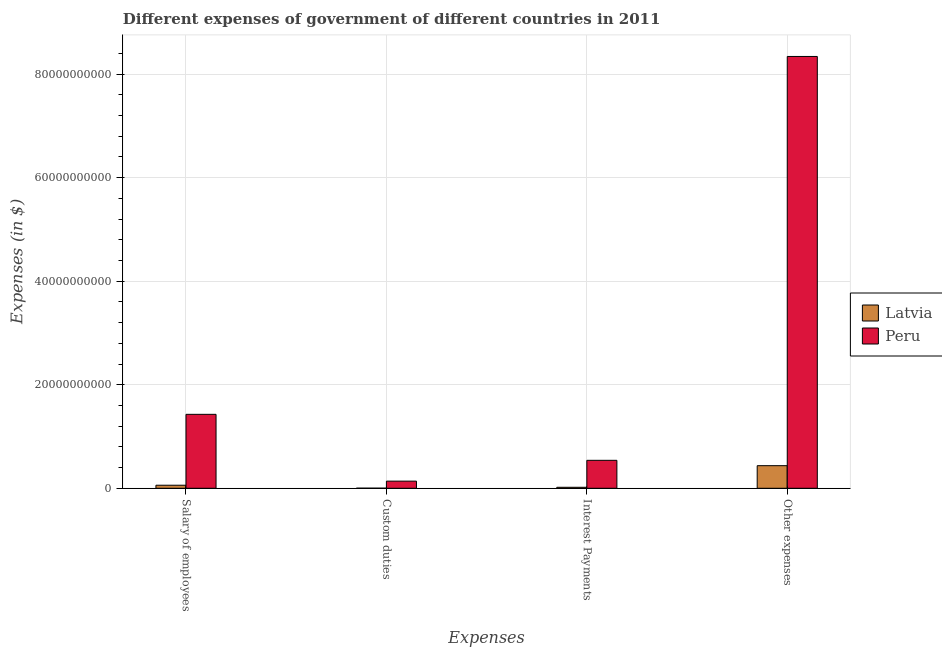How many different coloured bars are there?
Your answer should be compact. 2. How many bars are there on the 4th tick from the left?
Your answer should be very brief. 2. How many bars are there on the 4th tick from the right?
Keep it short and to the point. 2. What is the label of the 1st group of bars from the left?
Offer a terse response. Salary of employees. What is the amount spent on interest payments in Peru?
Offer a terse response. 5.40e+09. Across all countries, what is the maximum amount spent on interest payments?
Your response must be concise. 5.40e+09. Across all countries, what is the minimum amount spent on other expenses?
Your answer should be compact. 4.37e+09. In which country was the amount spent on custom duties minimum?
Keep it short and to the point. Latvia. What is the total amount spent on interest payments in the graph?
Your answer should be very brief. 5.59e+09. What is the difference between the amount spent on custom duties in Latvia and that in Peru?
Offer a very short reply. -1.36e+09. What is the difference between the amount spent on interest payments in Latvia and the amount spent on other expenses in Peru?
Provide a short and direct response. -8.32e+1. What is the average amount spent on custom duties per country?
Make the answer very short. 7.01e+08. What is the difference between the amount spent on interest payments and amount spent on other expenses in Peru?
Ensure brevity in your answer.  -7.80e+1. In how many countries, is the amount spent on custom duties greater than 68000000000 $?
Provide a succinct answer. 0. What is the ratio of the amount spent on custom duties in Peru to that in Latvia?
Your answer should be very brief. 66.15. Is the amount spent on custom duties in Latvia less than that in Peru?
Your response must be concise. Yes. Is the difference between the amount spent on custom duties in Peru and Latvia greater than the difference between the amount spent on salary of employees in Peru and Latvia?
Your response must be concise. No. What is the difference between the highest and the second highest amount spent on salary of employees?
Make the answer very short. 1.37e+1. What is the difference between the highest and the lowest amount spent on custom duties?
Your answer should be very brief. 1.36e+09. In how many countries, is the amount spent on other expenses greater than the average amount spent on other expenses taken over all countries?
Provide a succinct answer. 1. Is it the case that in every country, the sum of the amount spent on other expenses and amount spent on salary of employees is greater than the sum of amount spent on custom duties and amount spent on interest payments?
Your response must be concise. No. What does the 1st bar from the left in Interest Payments represents?
Your answer should be compact. Latvia. What does the 2nd bar from the right in Interest Payments represents?
Your response must be concise. Latvia. How many countries are there in the graph?
Keep it short and to the point. 2. Does the graph contain grids?
Your answer should be very brief. Yes. How many legend labels are there?
Give a very brief answer. 2. What is the title of the graph?
Give a very brief answer. Different expenses of government of different countries in 2011. Does "Sierra Leone" appear as one of the legend labels in the graph?
Your response must be concise. No. What is the label or title of the X-axis?
Offer a terse response. Expenses. What is the label or title of the Y-axis?
Your answer should be compact. Expenses (in $). What is the Expenses (in $) in Latvia in Salary of employees?
Offer a very short reply. 5.91e+08. What is the Expenses (in $) of Peru in Salary of employees?
Your answer should be compact. 1.43e+1. What is the Expenses (in $) in Latvia in Custom duties?
Ensure brevity in your answer.  2.09e+07. What is the Expenses (in $) of Peru in Custom duties?
Your response must be concise. 1.38e+09. What is the Expenses (in $) of Latvia in Interest Payments?
Make the answer very short. 1.91e+08. What is the Expenses (in $) of Peru in Interest Payments?
Your answer should be compact. 5.40e+09. What is the Expenses (in $) of Latvia in Other expenses?
Your response must be concise. 4.37e+09. What is the Expenses (in $) in Peru in Other expenses?
Ensure brevity in your answer.  8.34e+1. Across all Expenses, what is the maximum Expenses (in $) in Latvia?
Your answer should be compact. 4.37e+09. Across all Expenses, what is the maximum Expenses (in $) in Peru?
Keep it short and to the point. 8.34e+1. Across all Expenses, what is the minimum Expenses (in $) in Latvia?
Give a very brief answer. 2.09e+07. Across all Expenses, what is the minimum Expenses (in $) of Peru?
Keep it short and to the point. 1.38e+09. What is the total Expenses (in $) of Latvia in the graph?
Keep it short and to the point. 5.17e+09. What is the total Expenses (in $) in Peru in the graph?
Offer a terse response. 1.04e+11. What is the difference between the Expenses (in $) of Latvia in Salary of employees and that in Custom duties?
Offer a very short reply. 5.70e+08. What is the difference between the Expenses (in $) of Peru in Salary of employees and that in Custom duties?
Keep it short and to the point. 1.29e+1. What is the difference between the Expenses (in $) in Latvia in Salary of employees and that in Interest Payments?
Your response must be concise. 4.00e+08. What is the difference between the Expenses (in $) of Peru in Salary of employees and that in Interest Payments?
Offer a terse response. 8.88e+09. What is the difference between the Expenses (in $) of Latvia in Salary of employees and that in Other expenses?
Provide a succinct answer. -3.77e+09. What is the difference between the Expenses (in $) in Peru in Salary of employees and that in Other expenses?
Your answer should be compact. -6.91e+1. What is the difference between the Expenses (in $) of Latvia in Custom duties and that in Interest Payments?
Offer a terse response. -1.70e+08. What is the difference between the Expenses (in $) in Peru in Custom duties and that in Interest Payments?
Offer a very short reply. -4.02e+09. What is the difference between the Expenses (in $) in Latvia in Custom duties and that in Other expenses?
Your response must be concise. -4.34e+09. What is the difference between the Expenses (in $) of Peru in Custom duties and that in Other expenses?
Offer a very short reply. -8.20e+1. What is the difference between the Expenses (in $) in Latvia in Interest Payments and that in Other expenses?
Your response must be concise. -4.17e+09. What is the difference between the Expenses (in $) of Peru in Interest Payments and that in Other expenses?
Give a very brief answer. -7.80e+1. What is the difference between the Expenses (in $) in Latvia in Salary of employees and the Expenses (in $) in Peru in Custom duties?
Offer a terse response. -7.89e+08. What is the difference between the Expenses (in $) in Latvia in Salary of employees and the Expenses (in $) in Peru in Interest Payments?
Offer a very short reply. -4.81e+09. What is the difference between the Expenses (in $) in Latvia in Salary of employees and the Expenses (in $) in Peru in Other expenses?
Offer a terse response. -8.28e+1. What is the difference between the Expenses (in $) of Latvia in Custom duties and the Expenses (in $) of Peru in Interest Payments?
Your response must be concise. -5.38e+09. What is the difference between the Expenses (in $) of Latvia in Custom duties and the Expenses (in $) of Peru in Other expenses?
Provide a short and direct response. -8.34e+1. What is the difference between the Expenses (in $) of Latvia in Interest Payments and the Expenses (in $) of Peru in Other expenses?
Offer a terse response. -8.32e+1. What is the average Expenses (in $) of Latvia per Expenses?
Offer a terse response. 1.29e+09. What is the average Expenses (in $) of Peru per Expenses?
Your answer should be compact. 2.61e+1. What is the difference between the Expenses (in $) of Latvia and Expenses (in $) of Peru in Salary of employees?
Ensure brevity in your answer.  -1.37e+1. What is the difference between the Expenses (in $) of Latvia and Expenses (in $) of Peru in Custom duties?
Give a very brief answer. -1.36e+09. What is the difference between the Expenses (in $) of Latvia and Expenses (in $) of Peru in Interest Payments?
Ensure brevity in your answer.  -5.21e+09. What is the difference between the Expenses (in $) of Latvia and Expenses (in $) of Peru in Other expenses?
Offer a terse response. -7.90e+1. What is the ratio of the Expenses (in $) of Latvia in Salary of employees to that in Custom duties?
Keep it short and to the point. 28.32. What is the ratio of the Expenses (in $) of Peru in Salary of employees to that in Custom duties?
Your answer should be very brief. 10.35. What is the ratio of the Expenses (in $) of Latvia in Salary of employees to that in Interest Payments?
Provide a succinct answer. 3.09. What is the ratio of the Expenses (in $) of Peru in Salary of employees to that in Interest Payments?
Offer a very short reply. 2.64. What is the ratio of the Expenses (in $) in Latvia in Salary of employees to that in Other expenses?
Make the answer very short. 0.14. What is the ratio of the Expenses (in $) in Peru in Salary of employees to that in Other expenses?
Give a very brief answer. 0.17. What is the ratio of the Expenses (in $) in Latvia in Custom duties to that in Interest Payments?
Your answer should be compact. 0.11. What is the ratio of the Expenses (in $) in Peru in Custom duties to that in Interest Payments?
Provide a short and direct response. 0.26. What is the ratio of the Expenses (in $) of Latvia in Custom duties to that in Other expenses?
Give a very brief answer. 0. What is the ratio of the Expenses (in $) of Peru in Custom duties to that in Other expenses?
Provide a short and direct response. 0.02. What is the ratio of the Expenses (in $) in Latvia in Interest Payments to that in Other expenses?
Provide a short and direct response. 0.04. What is the ratio of the Expenses (in $) in Peru in Interest Payments to that in Other expenses?
Provide a short and direct response. 0.06. What is the difference between the highest and the second highest Expenses (in $) in Latvia?
Keep it short and to the point. 3.77e+09. What is the difference between the highest and the second highest Expenses (in $) of Peru?
Offer a very short reply. 6.91e+1. What is the difference between the highest and the lowest Expenses (in $) of Latvia?
Keep it short and to the point. 4.34e+09. What is the difference between the highest and the lowest Expenses (in $) of Peru?
Offer a very short reply. 8.20e+1. 